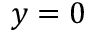<formula> <loc_0><loc_0><loc_500><loc_500>y = 0</formula> 